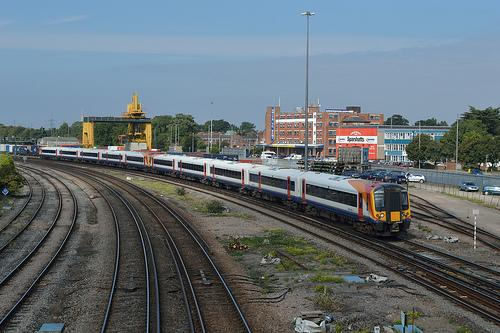Provide a brief overview of the various elements present in the image. The image shows a train on tracks, silver sedan car, parked cars, trees, buildings, a lamp post, a sky with clouds, and patches of grass. Elaborate on the meteorological conditions visible in the image. The image exhibits a blue sky with some white clouds, providing a partially clear and cheerful atmosphere in the area. Describe the landscape and objects between train tracks in the image. The land between train tracks shows litter, sprinkled grass, and a train track switching mechanism. Narrate a brief description of the train and its surroundings in the image. A long white and blue train is passing through the railway lines, with a yellow front, surrounded by cars, trees, and buildings. What is the state of the environment depicted in the image? The environment shows a downtown area with a busy train yard, railway lines, cars, and trees scattered between buildings. Provide a short description of the automobiles visible in the image. Cars are parked on the street, including a silver sedan and other vehicles in a parking lot near the railroad tracks. Mention the dominant colors present in the image's sky and the foliage of trees. The sky comprises of blue and white colors due to some clouds, while the foliage of trees mainly exhibits a green color. State what type of transportation is most prominently displayed in the image. The image prominently displays a train as the primary transportation mode, passing through a railyard. Write about the central object in the image and its relation to other objects. The central object is a train on railway lines, surrounded by buildings, trees, cars, and a lamp post in a downtown area. Give a quick summary of the environment and structures depicted in the image. The image captures an urban scene with a train, railway lines, cars, and a blend of trees and buildings in the background. 